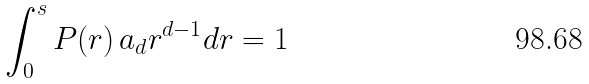Convert formula to latex. <formula><loc_0><loc_0><loc_500><loc_500>\int _ { 0 } ^ { s } P ( r ) \, a _ { d } r ^ { d - 1 } d r = 1</formula> 